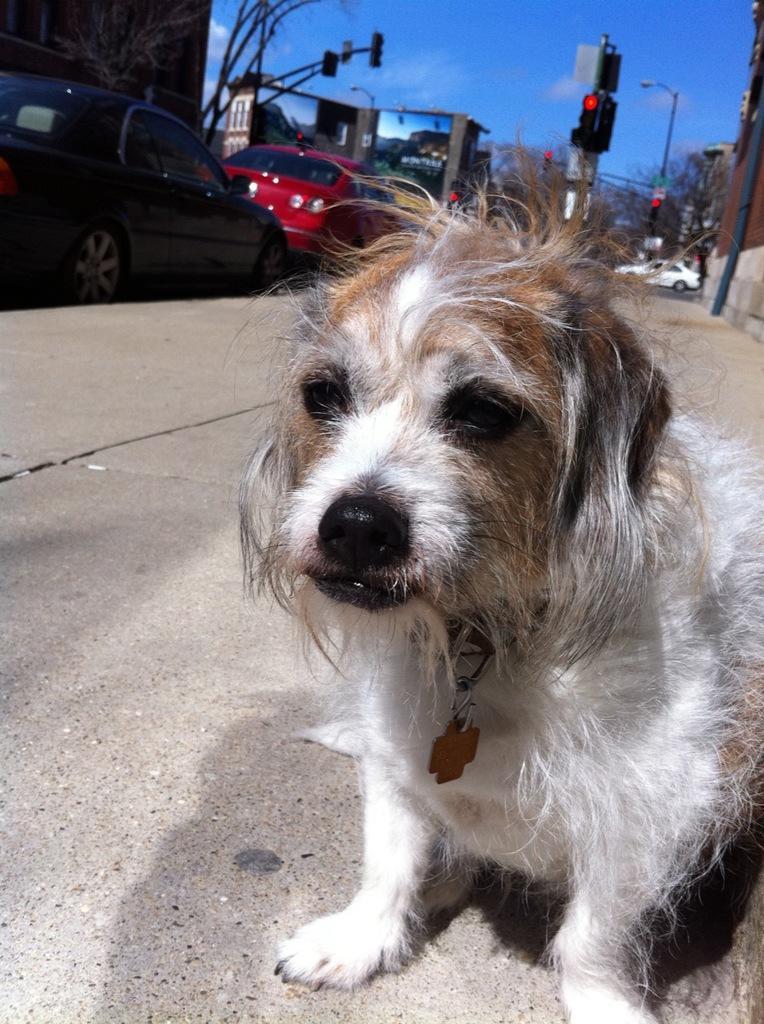Can you describe this image briefly? In this image we can see a dog on the ground. In the background, we can see a group of cars parked on the road, group of traffic lights, buildings and the sky. 